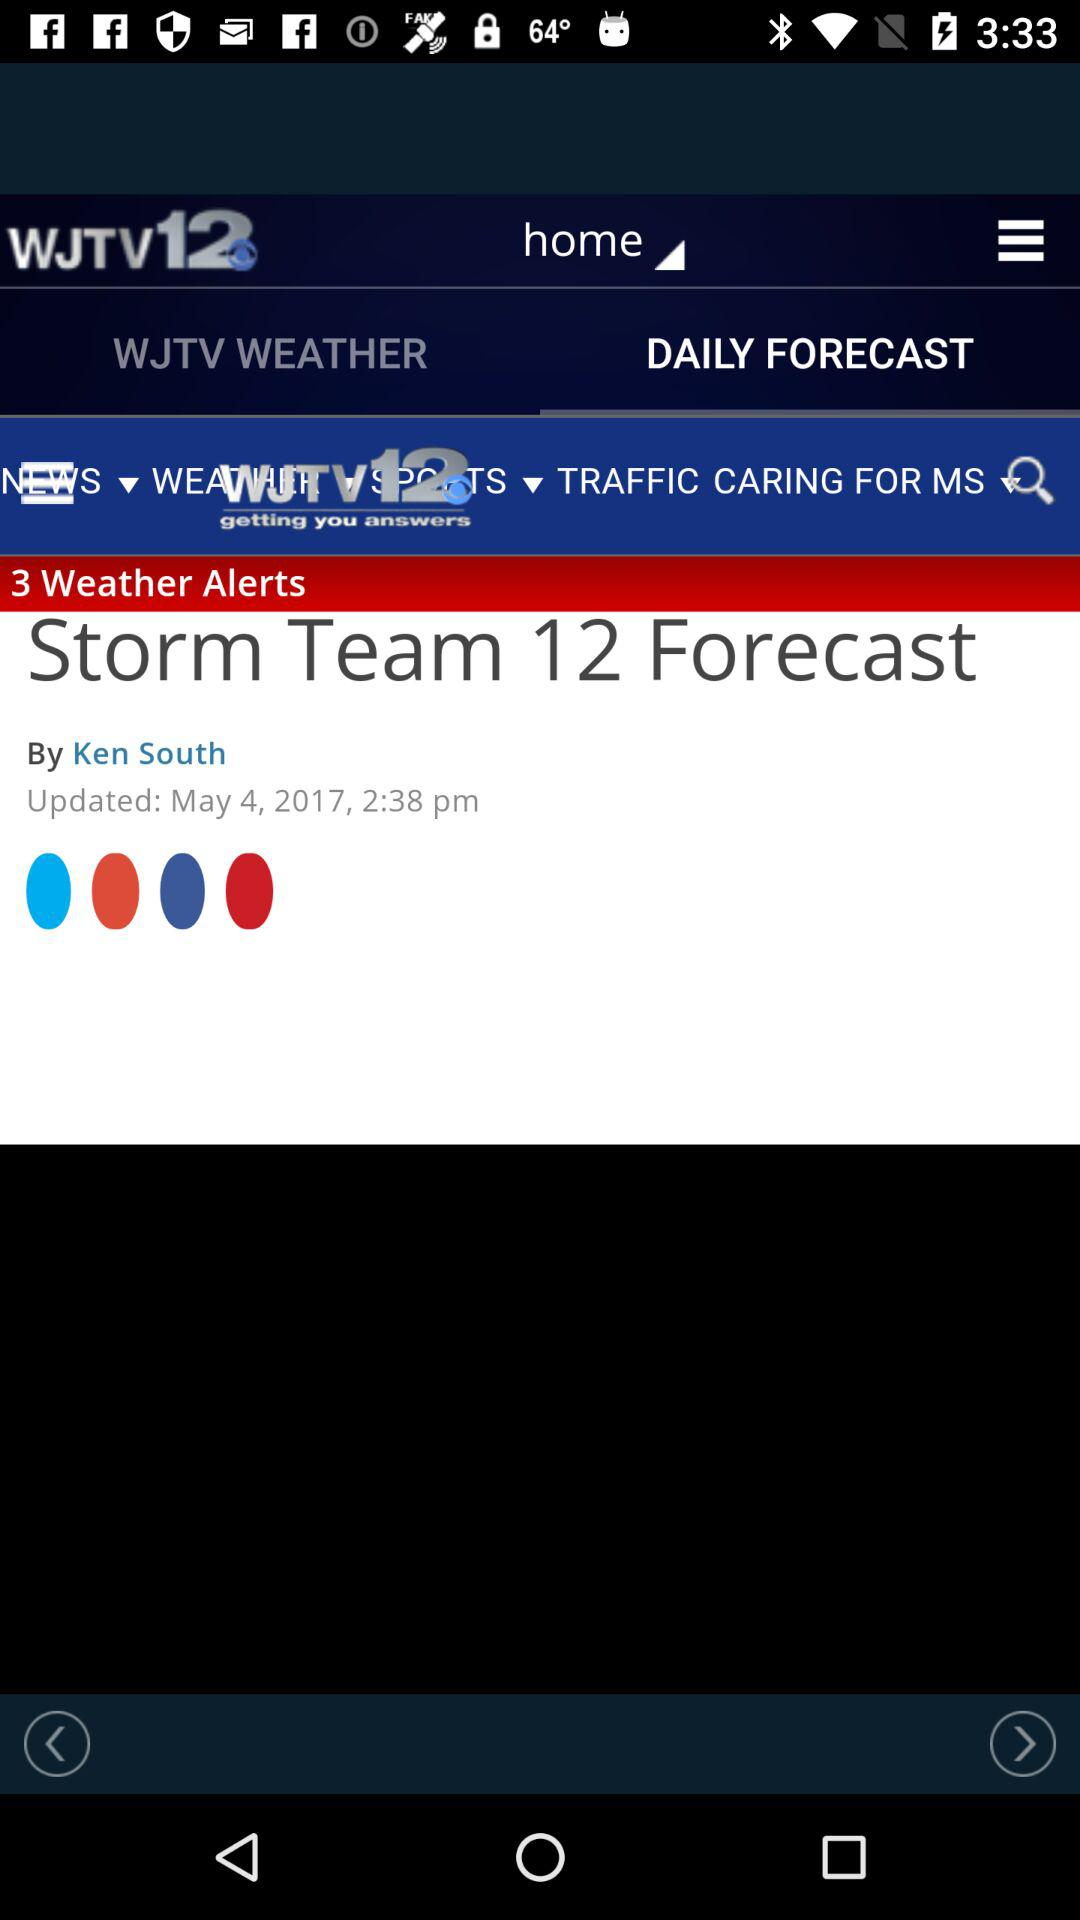What is the date of the post posted by Ken South? The date of the post is May 4, 2017. 